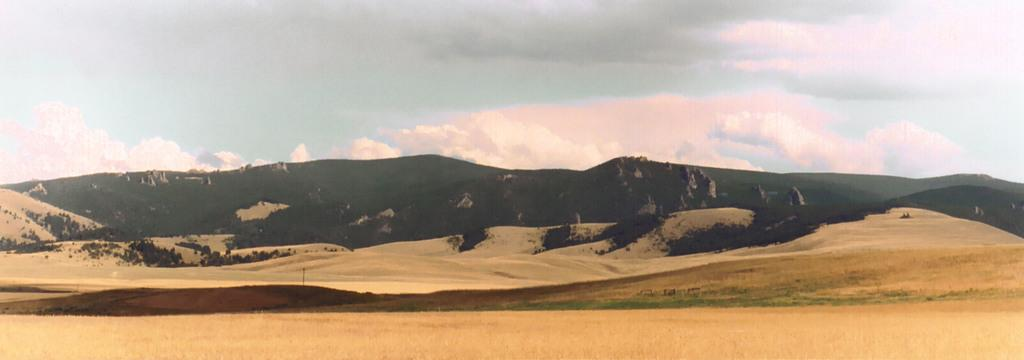What type of natural landform can be seen in the image? There are mountains in the image. What type of vegetation is present in the image? There are trees in the image. What object can be seen standing upright in the image? There is a pole in the image. What is visible in the background of the image? The sky is visible in the background of the image. Where are the cherries growing in the image? There are no cherries present in the image. What type of animal can be seen hopping near the trees in the image? There is no animal, specifically a rabbit, present in the image. 